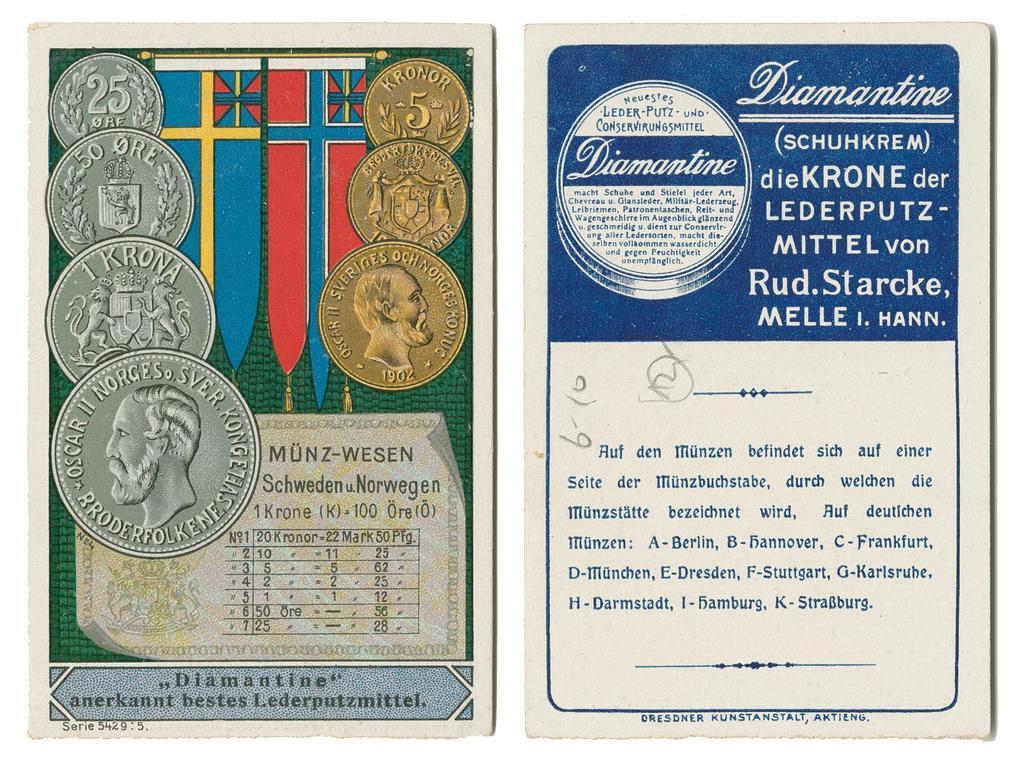How much is the top silver coin worth?
Give a very brief answer. 25. 